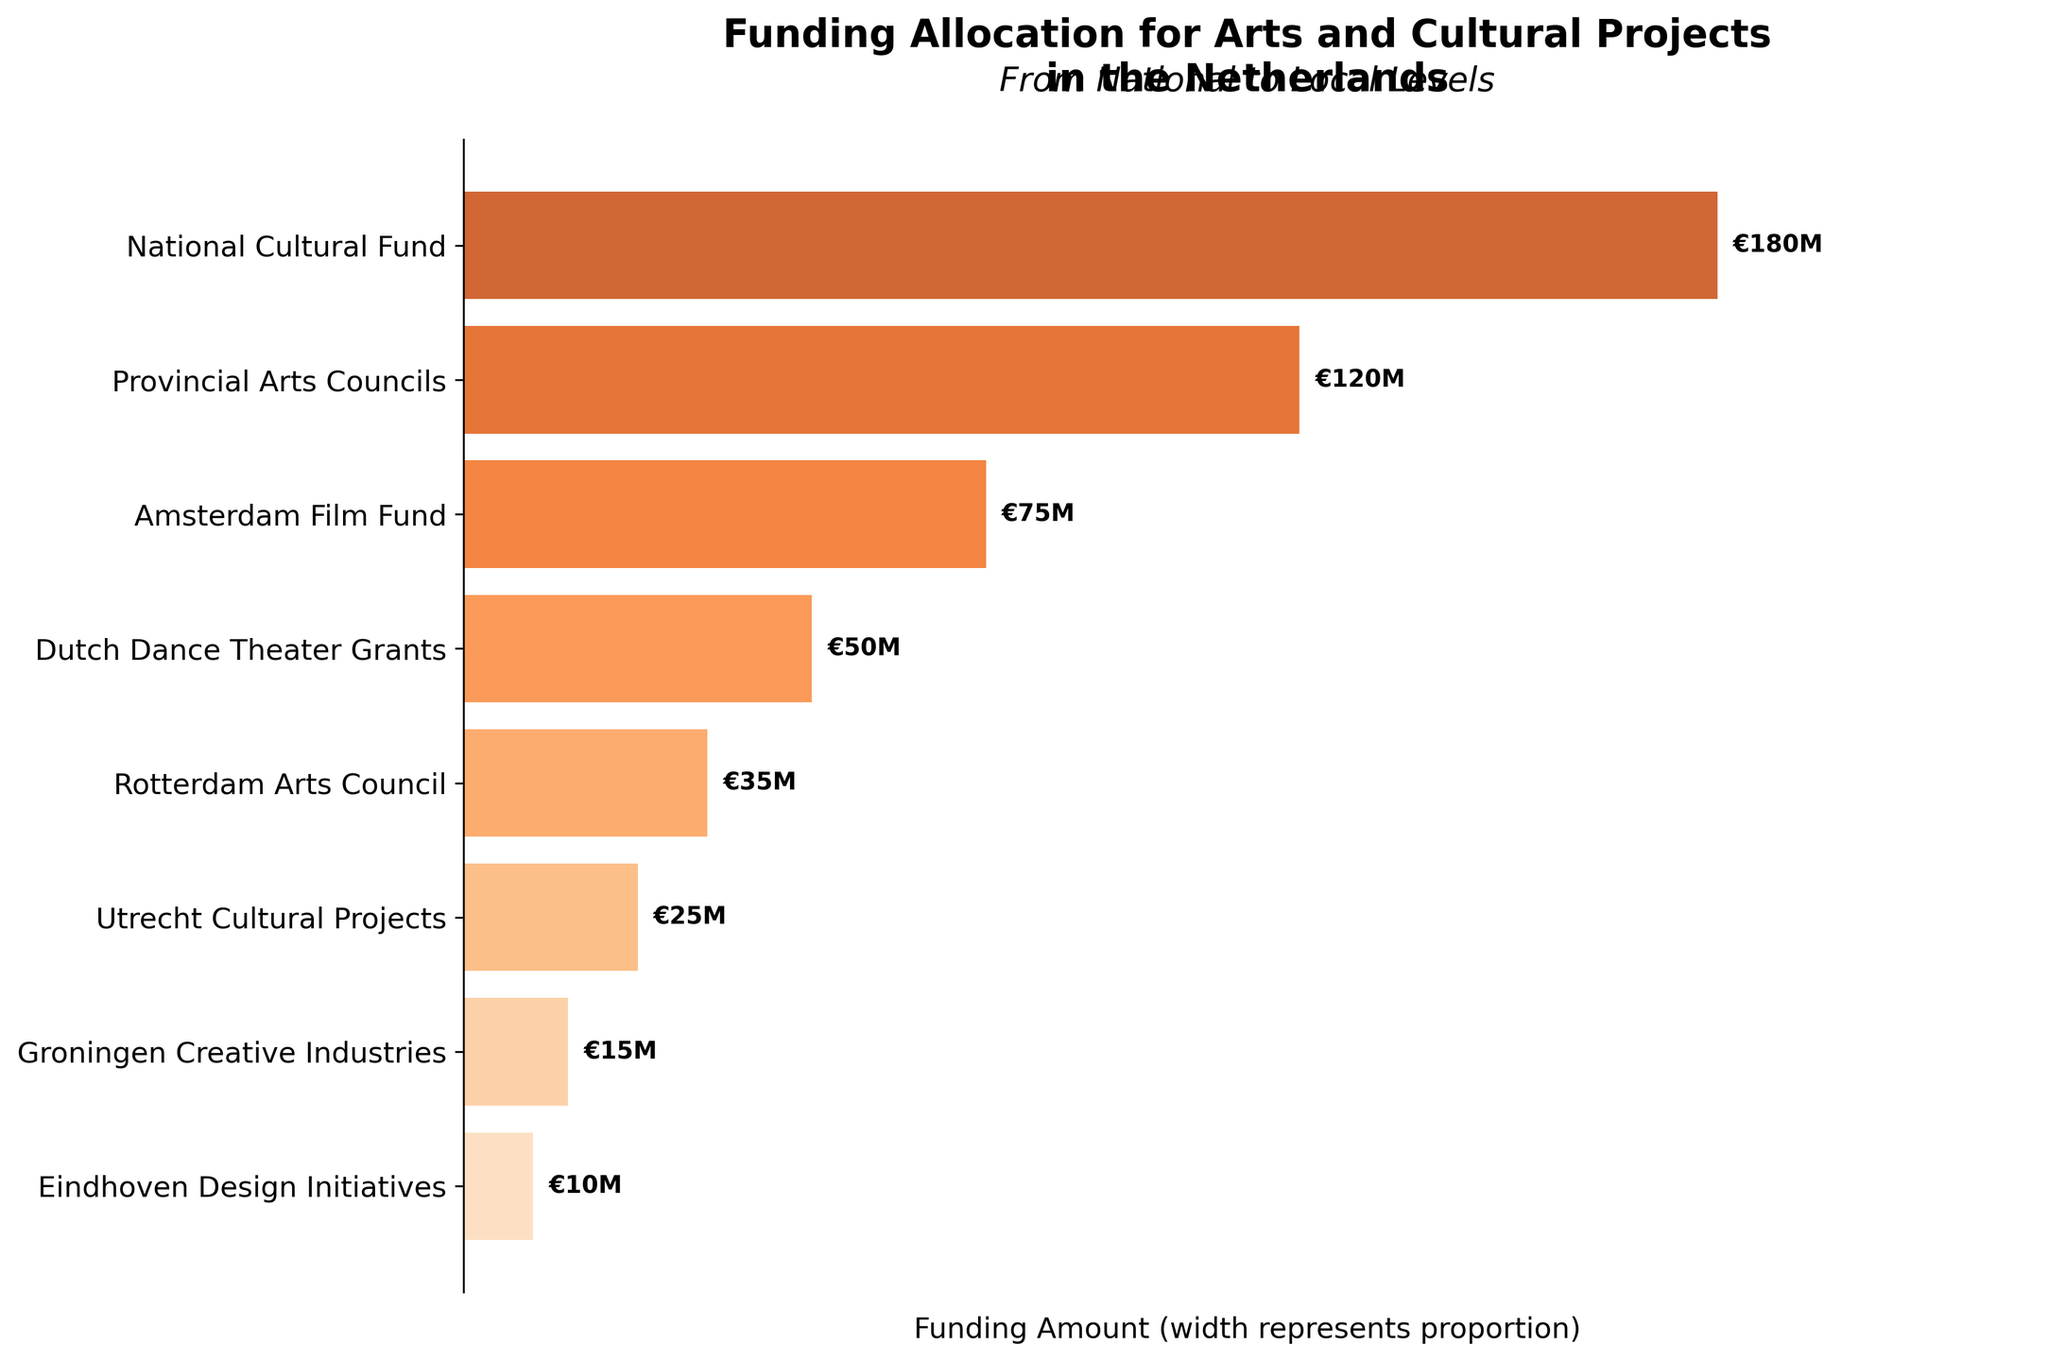what is the title of the plot? The title is usually located in a prominent position at the top of the plot. By looking at the plot, we can identify the text that acts as the heading.
Answer: Funding Allocation for Arts and Cultural Projects in the Netherlands What is the total amount of funding allocated for local cultural projects? The local cultural projects include categories such as Rotterdam Arts Council, Utrecht Cultural Projects, Groningen Creative Industries, and Eindhoven Design Initiatives. Sum these values to find the total. 35 + 25 + 15 + 10 = 85.
Answer: €85M Which category received more funding between Amsterdam Film Fund and Dutch Dance Theater Grants? From the plot, we can see the funding values for both Amsterdam Film Fund and Dutch Dance Theater Grants. Compare the values directly. €75M for Amsterdam Film Fund and €50M for Dutch Dance Theater Grants. Clearly, Amsterdam Film Fund received more.
Answer: Amsterdam Film Fund What is the percentage difference in funding between the National Cultural Fund and Provincial Arts Councils? First, find the difference between the funding amounts: €180M - €120M = €60M. Then, to find the percentage difference relative to Provincial Arts Councils: (60 / 120) * 100% = 50%.
Answer: 50% Does the National Cultural Fund's funding make up more than half of the total funding shown in the plot? First, calculate the total funding: 180 + 120 + 75 + 50 + 35 + 25 + 15 + 10 = 510M euros. Then, determine if the funding for the National Cultural Fund constitutes more than half: (180 / 510) * 100% = approximately 35.29%, which is less than half.
Answer: No What is the average funding amount across all categories? To find the average, sum up all funding amounts and divide by the number of categories. Sum: 180 + 120 + 75 + 50 + 35 + 25 + 15 + 10 = 510. Number of categories = 8. So, 510 / 8 = 63.75.
Answer: €63.75M How much more funding does the Amsterdam Film Fund receive compared to the Eindhoven Design Initiatives? From the plot, find the funding amounts for Amsterdam Film Fund and Eindhoven Design Initiatives, and subtract the latter from the former: €75M - €10M = €65M.
Answer: €65M Which level (National, Provincial, Major Cities, or Local) gets the most diverse funding allocations? Observe the number of distinct categories within each level. National has 1, Provincial has 1, Major Cities (Amsterdam, Rotterdam, Utrecht) have 3, Local (Groningen, Eindhoven) have 2. Major Cities have the most categories (3).
Answer: Major Cities What is the sum of funding for the categories at the city level? The city-level categories are Amsterdam Film Fund, Dutch Dance Theater Grants, Rotterdam Arts Council, and Utrecht Cultural Projects. Sum these funding amounts: 75 + 50 + 35 + 25 = 185.
Answer: €185M 